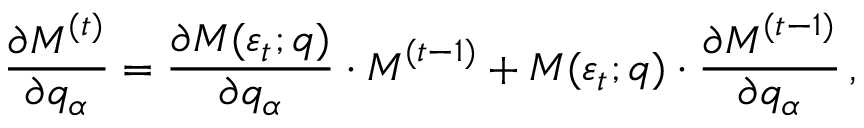Convert formula to latex. <formula><loc_0><loc_0><loc_500><loc_500>\frac { \partial M ^ { ( t ) } } { \partial q _ { \alpha } } = \frac { \partial M ( \varepsilon _ { t } ; q ) } { \partial q _ { \alpha } } \cdot M ^ { ( t - 1 ) } + M ( \varepsilon _ { t } ; q ) \cdot \frac { \partial M ^ { ( t - 1 ) } } { \partial q _ { \alpha } } \, ,</formula> 